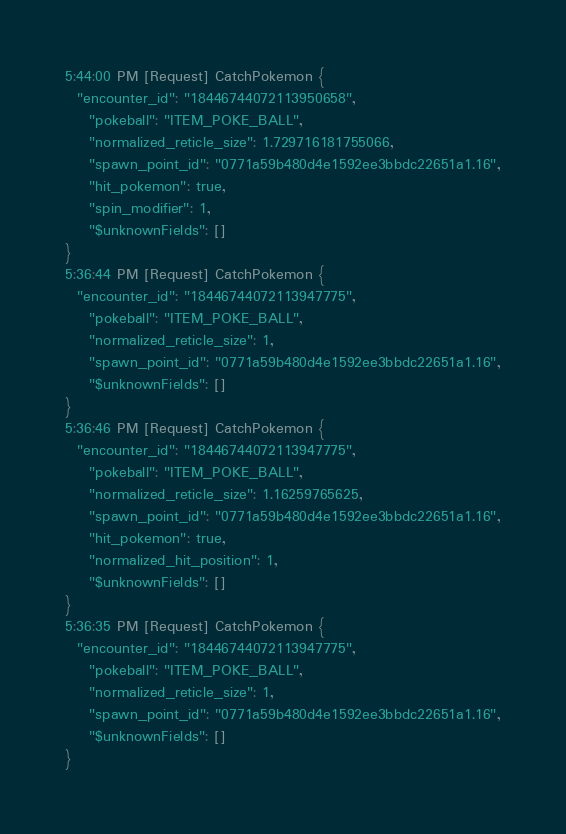Convert code to text. <code><loc_0><loc_0><loc_500><loc_500><_JavaScript_>5:44:00 PM [Request] CatchPokemon {
  "encounter_id": "18446744072113950658",
    "pokeball": "ITEM_POKE_BALL",
    "normalized_reticle_size": 1.729716181755066,
    "spawn_point_id": "0771a59b480d4e1592ee3bbdc22651a1.16",
    "hit_pokemon": true,
    "spin_modifier": 1,
    "$unknownFields": []
}
5:36:44 PM [Request] CatchPokemon {
  "encounter_id": "18446744072113947775",
    "pokeball": "ITEM_POKE_BALL",
    "normalized_reticle_size": 1,
    "spawn_point_id": "0771a59b480d4e1592ee3bbdc22651a1.16",
    "$unknownFields": []
}
5:36:46 PM [Request] CatchPokemon {
  "encounter_id": "18446744072113947775",
    "pokeball": "ITEM_POKE_BALL",
    "normalized_reticle_size": 1.16259765625,
    "spawn_point_id": "0771a59b480d4e1592ee3bbdc22651a1.16",
    "hit_pokemon": true,
    "normalized_hit_position": 1,
    "$unknownFields": []
}
5:36:35 PM [Request] CatchPokemon {
  "encounter_id": "18446744072113947775",
    "pokeball": "ITEM_POKE_BALL",
    "normalized_reticle_size": 1,
    "spawn_point_id": "0771a59b480d4e1592ee3bbdc22651a1.16",
    "$unknownFields": []
}
</code> 